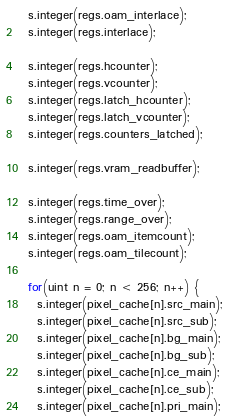<code> <loc_0><loc_0><loc_500><loc_500><_C++_>  s.integer(regs.oam_interlace);
  s.integer(regs.interlace);

  s.integer(regs.hcounter);
  s.integer(regs.vcounter);
  s.integer(regs.latch_hcounter);
  s.integer(regs.latch_vcounter);
  s.integer(regs.counters_latched);

  s.integer(regs.vram_readbuffer);

  s.integer(regs.time_over);
  s.integer(regs.range_over);
  s.integer(regs.oam_itemcount);
  s.integer(regs.oam_tilecount);

  for(uint n = 0; n < 256; n++) {
    s.integer(pixel_cache[n].src_main);
    s.integer(pixel_cache[n].src_sub);
    s.integer(pixel_cache[n].bg_main);
    s.integer(pixel_cache[n].bg_sub);
    s.integer(pixel_cache[n].ce_main);
    s.integer(pixel_cache[n].ce_sub);
    s.integer(pixel_cache[n].pri_main);</code> 